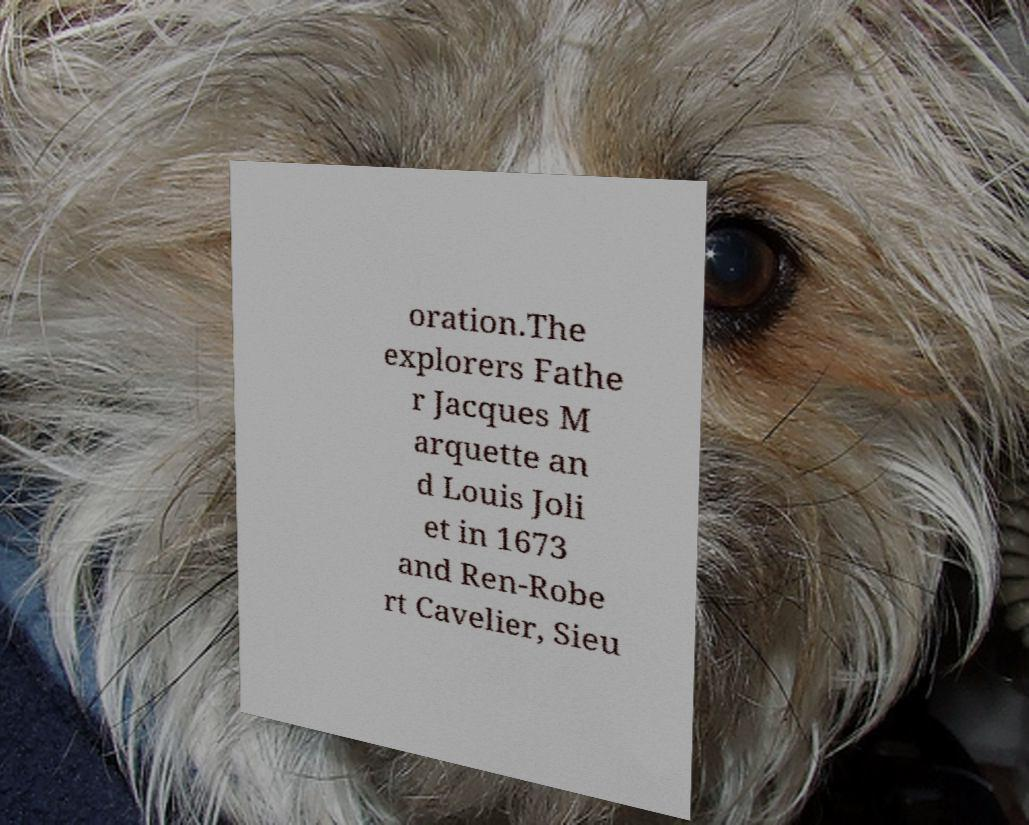For documentation purposes, I need the text within this image transcribed. Could you provide that? oration.The explorers Fathe r Jacques M arquette an d Louis Joli et in 1673 and Ren-Robe rt Cavelier, Sieu 